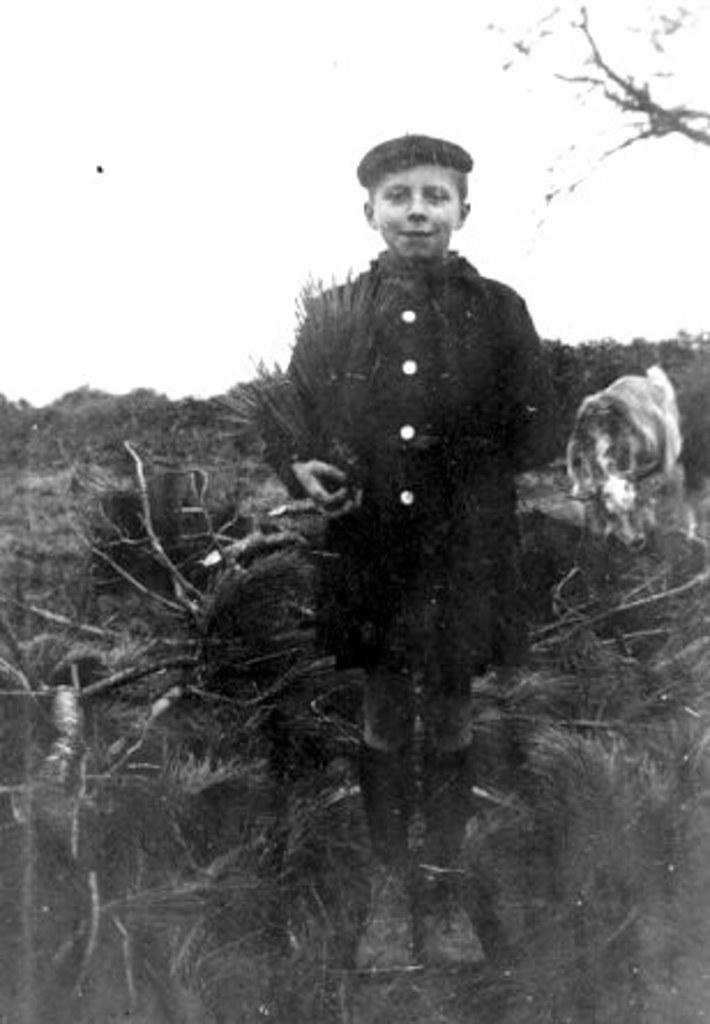Who is the main subject in the image? There is a boy in the image. What is the boy holding in the image? The boy is holding a bunch of grass. What animal can be seen behind the boy? There is a cow behind the boy. What type of vegetation is visible in the background of the image? There are trees visible at the back side of the image. What color is the door in the image? There is no door present in the image. What does the boy need to do in the image? The image does not provide any information about what the boy needs to do; it only shows him holding a bunch of grass and standing near a cow. 